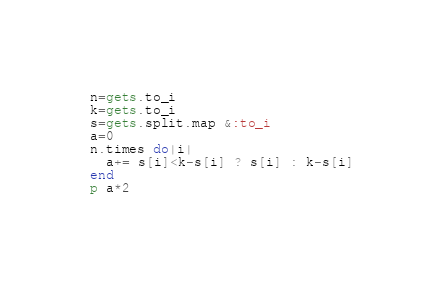Convert code to text. <code><loc_0><loc_0><loc_500><loc_500><_Ruby_>n=gets.to_i
k=gets.to_i
s=gets.split.map &:to_i
a=0
n.times do|i|
  a+= s[i]<k-s[i] ? s[i] : k-s[i]
end
p a*2
</code> 